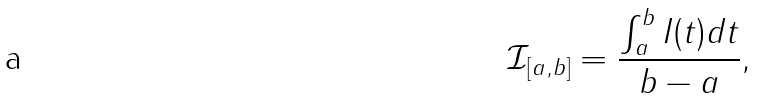<formula> <loc_0><loc_0><loc_500><loc_500>\mathcal { I } _ { [ a , b ] } = \frac { \int _ { a } ^ { b } I ( t ) d t } { b - a } ,</formula> 